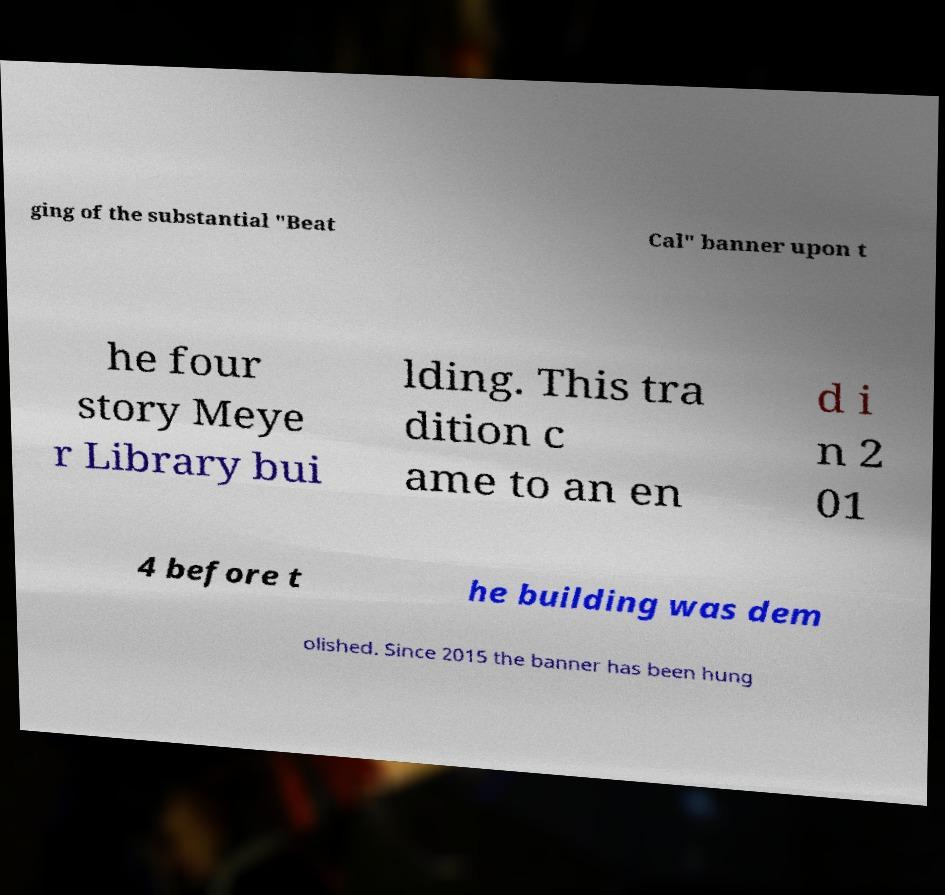There's text embedded in this image that I need extracted. Can you transcribe it verbatim? ging of the substantial "Beat Cal" banner upon t he four story Meye r Library bui lding. This tra dition c ame to an en d i n 2 01 4 before t he building was dem olished. Since 2015 the banner has been hung 